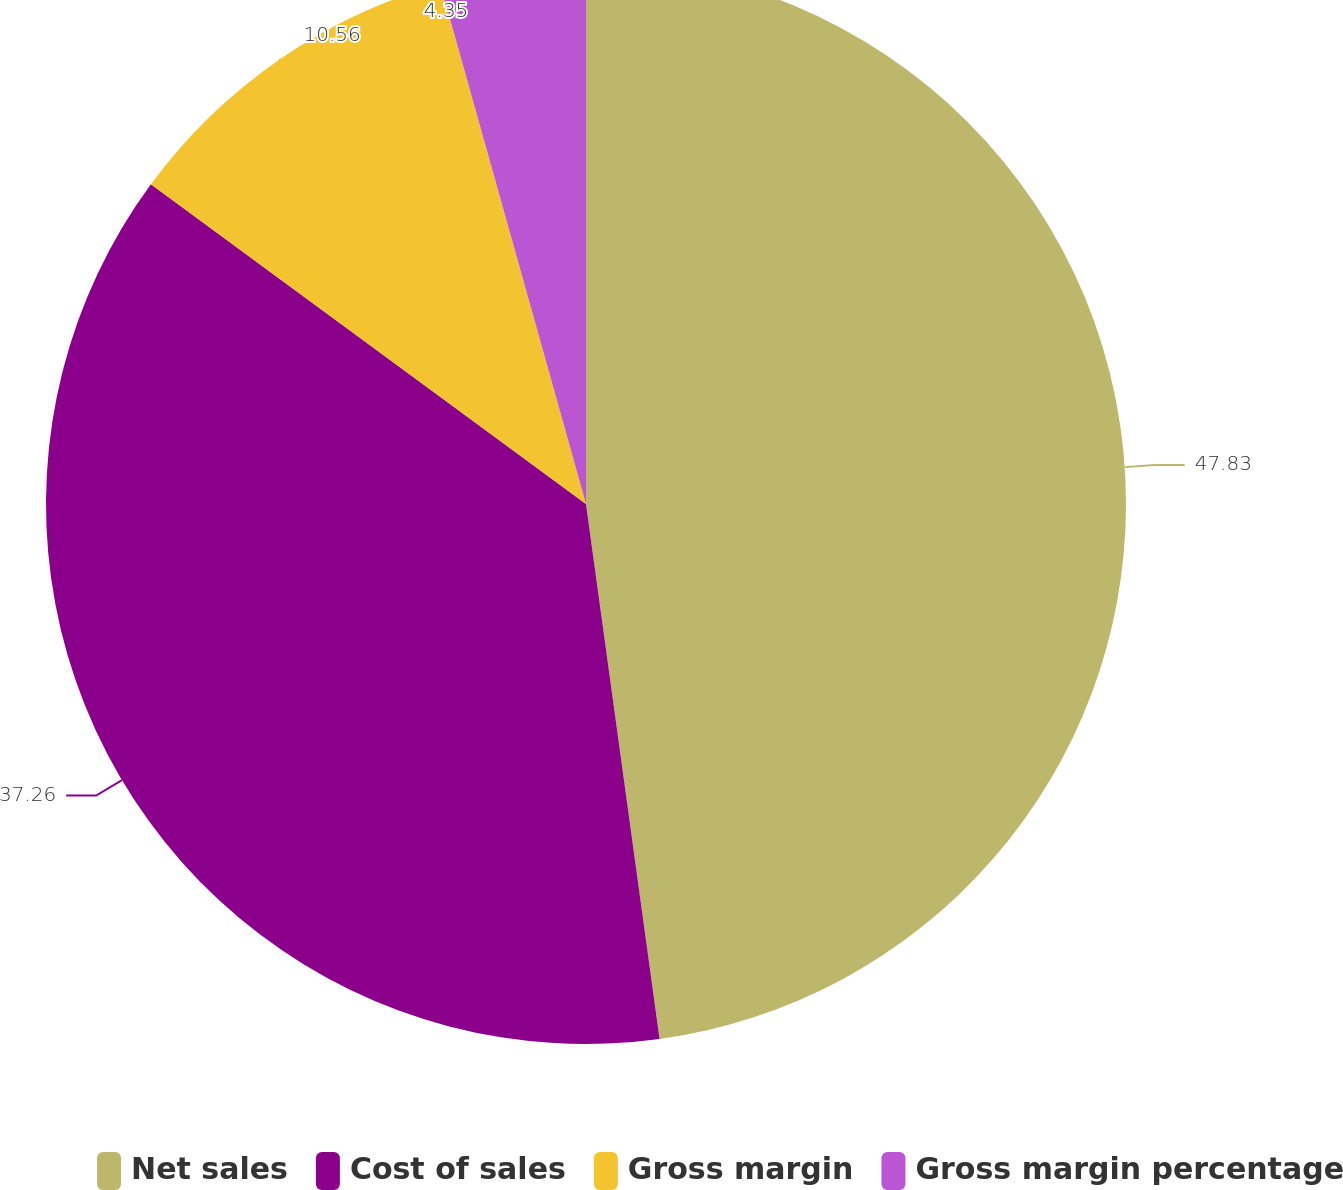Convert chart. <chart><loc_0><loc_0><loc_500><loc_500><pie_chart><fcel>Net sales<fcel>Cost of sales<fcel>Gross margin<fcel>Gross margin percentage<nl><fcel>47.82%<fcel>37.26%<fcel>10.56%<fcel>4.35%<nl></chart> 